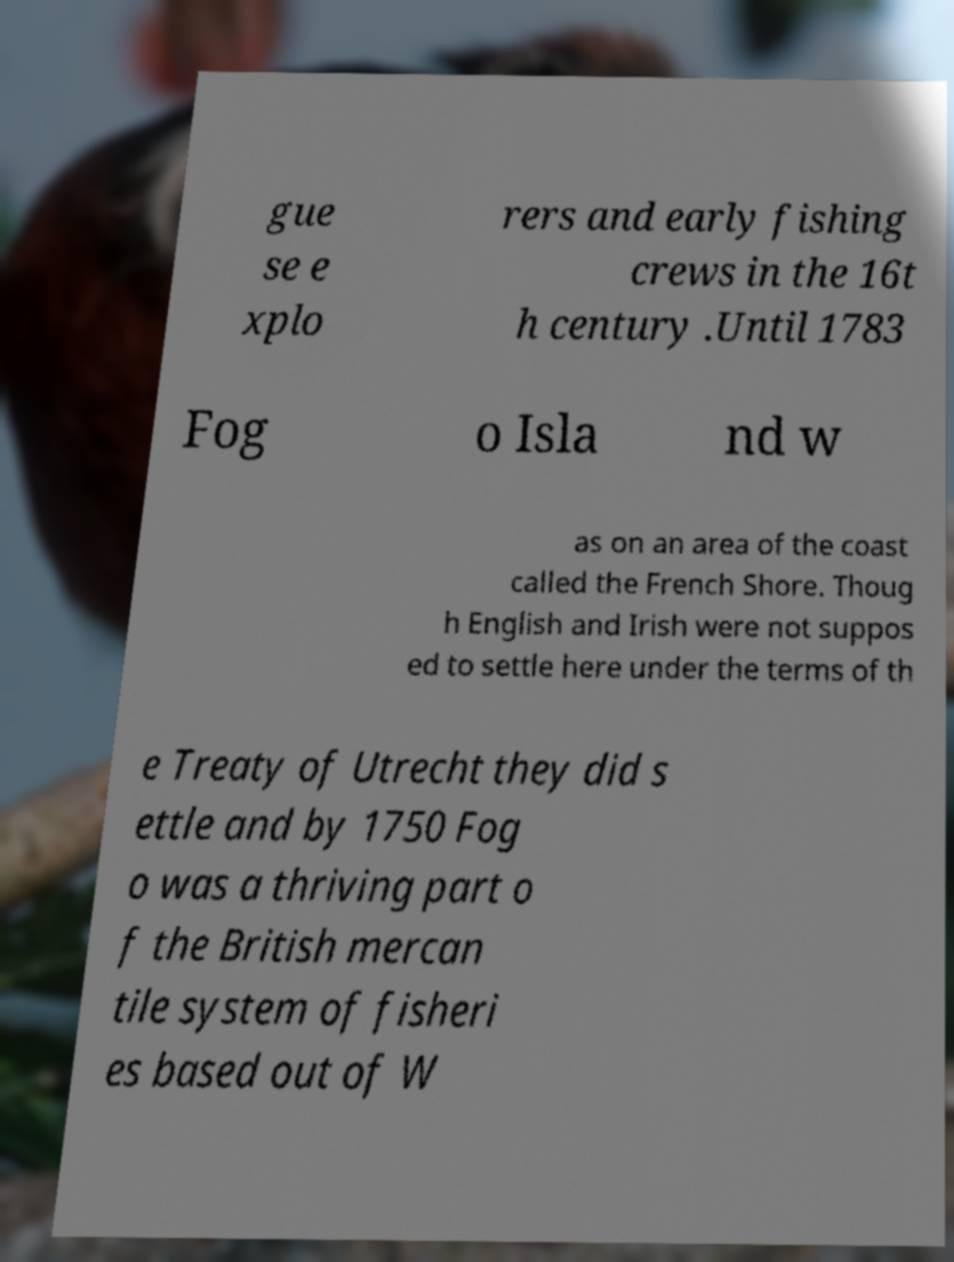Can you read and provide the text displayed in the image?This photo seems to have some interesting text. Can you extract and type it out for me? gue se e xplo rers and early fishing crews in the 16t h century .Until 1783 Fog o Isla nd w as on an area of the coast called the French Shore. Thoug h English and Irish were not suppos ed to settle here under the terms of th e Treaty of Utrecht they did s ettle and by 1750 Fog o was a thriving part o f the British mercan tile system of fisheri es based out of W 